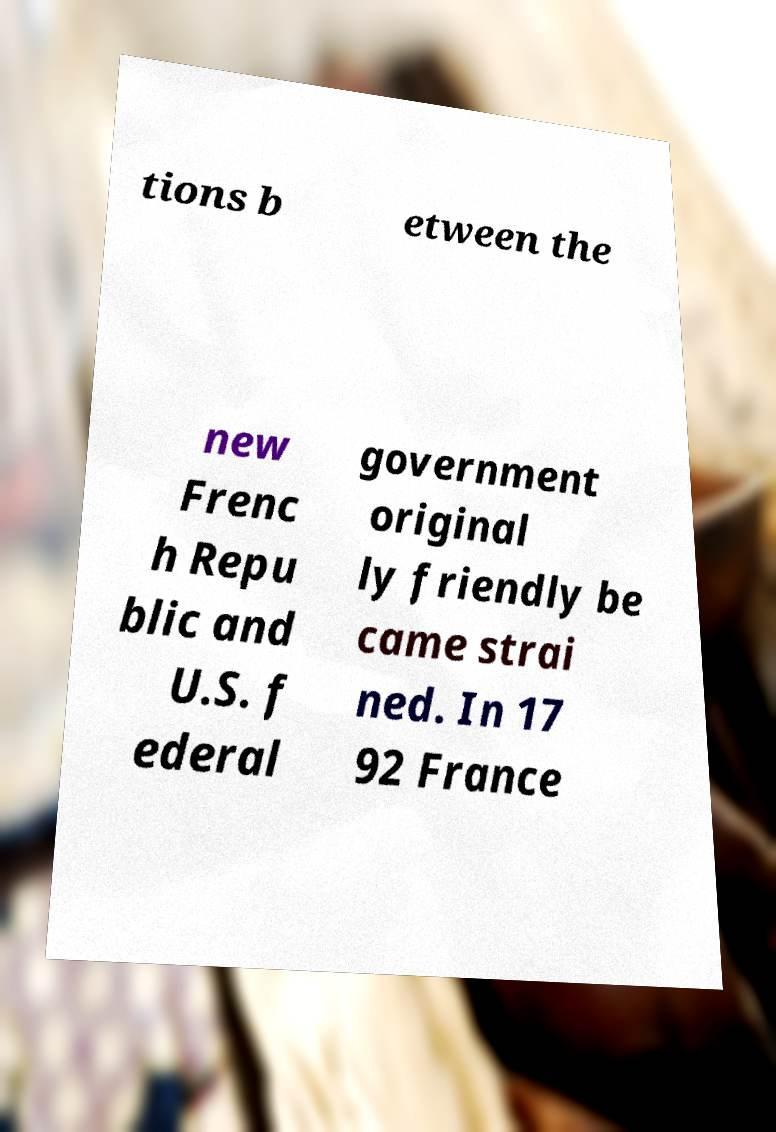Please identify and transcribe the text found in this image. tions b etween the new Frenc h Repu blic and U.S. f ederal government original ly friendly be came strai ned. In 17 92 France 